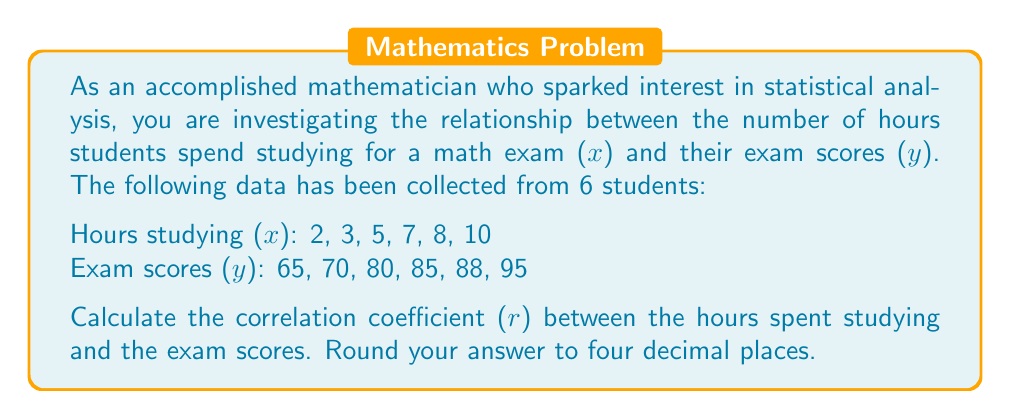Solve this math problem. To calculate the correlation coefficient (r), we'll use the formula:

$$ r = \frac{n\sum xy - \sum x \sum y}{\sqrt{[n\sum x^2 - (\sum x)^2][n\sum y^2 - (\sum y)^2]}} $$

Where:
n = number of pairs of data
x = hours studying
y = exam scores

Step 1: Calculate the required sums:
$\sum x = 2 + 3 + 5 + 7 + 8 + 10 = 35$
$\sum y = 65 + 70 + 80 + 85 + 88 + 95 = 483$
$\sum xy = (2)(65) + (3)(70) + (5)(80) + (7)(85) + (8)(88) + (10)(95) = 2960$
$\sum x^2 = 2^2 + 3^2 + 5^2 + 7^2 + 8^2 + 10^2 = 271$
$\sum y^2 = 65^2 + 70^2 + 80^2 + 85^2 + 88^2 + 95^2 = 39,489$

Step 2: Substitute these values into the formula:

$$ r = \frac{6(2960) - (35)(483)}{\sqrt{[6(271) - (35)^2][6(39489) - (483)^2]}} $$

Step 3: Solve the equation:

$$ r = \frac{17760 - 16905}{\sqrt{(1626 - 1225)(236934 - 233289)}} $$

$$ r = \frac{855}{\sqrt{(401)(3645)}} $$

$$ r = \frac{855}{\sqrt{1461645}} $$

$$ r = \frac{855}{1209.0} $$

$$ r \approx 0.7072 $$
Answer: The correlation coefficient (r) between hours spent studying and exam scores is approximately 0.7072. 